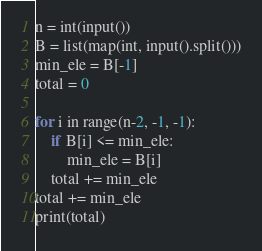<code> <loc_0><loc_0><loc_500><loc_500><_Python_>n = int(input())
B = list(map(int, input().split()))
min_ele = B[-1]
total = 0

for i in range(n-2, -1, -1):
	if B[i] <= min_ele:
		min_ele = B[i]
	total += min_ele
total += min_ele
print(total)</code> 